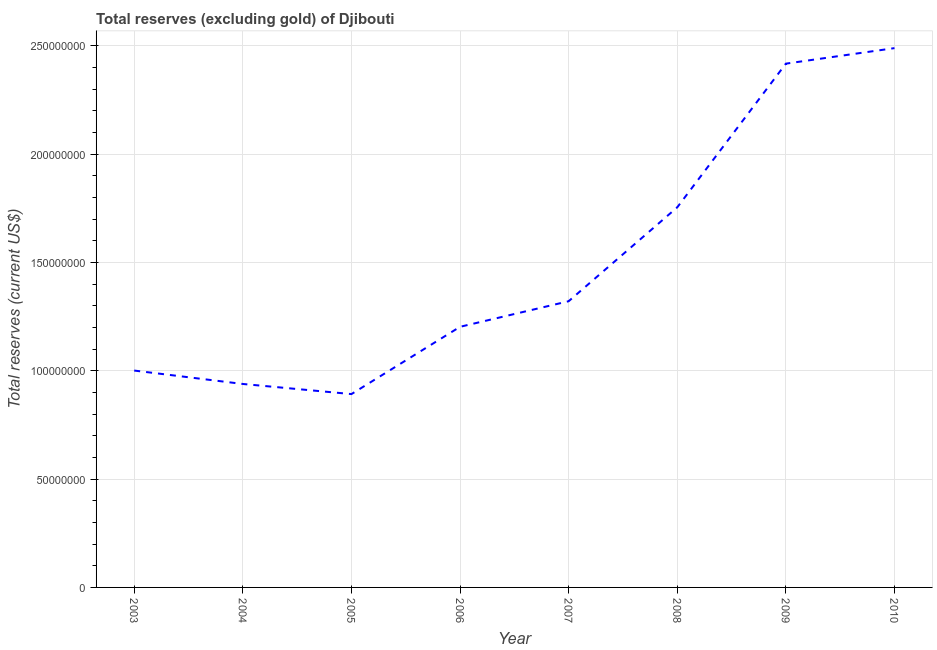What is the total reserves (excluding gold) in 2008?
Give a very brief answer. 1.75e+08. Across all years, what is the maximum total reserves (excluding gold)?
Ensure brevity in your answer.  2.49e+08. Across all years, what is the minimum total reserves (excluding gold)?
Keep it short and to the point. 8.93e+07. In which year was the total reserves (excluding gold) minimum?
Ensure brevity in your answer.  2005. What is the sum of the total reserves (excluding gold)?
Your response must be concise. 1.20e+09. What is the difference between the total reserves (excluding gold) in 2006 and 2008?
Your answer should be compact. -5.52e+07. What is the average total reserves (excluding gold) per year?
Make the answer very short. 1.50e+08. What is the median total reserves (excluding gold)?
Your response must be concise. 1.26e+08. Do a majority of the years between 2010 and 2005 (inclusive) have total reserves (excluding gold) greater than 100000000 US$?
Your answer should be compact. Yes. What is the ratio of the total reserves (excluding gold) in 2006 to that in 2010?
Your answer should be compact. 0.48. Is the total reserves (excluding gold) in 2006 less than that in 2008?
Offer a terse response. Yes. What is the difference between the highest and the second highest total reserves (excluding gold)?
Make the answer very short. 7.17e+06. What is the difference between the highest and the lowest total reserves (excluding gold)?
Your answer should be very brief. 1.60e+08. In how many years, is the total reserves (excluding gold) greater than the average total reserves (excluding gold) taken over all years?
Make the answer very short. 3. Does the total reserves (excluding gold) monotonically increase over the years?
Provide a short and direct response. No. Are the values on the major ticks of Y-axis written in scientific E-notation?
Your answer should be compact. No. What is the title of the graph?
Your answer should be compact. Total reserves (excluding gold) of Djibouti. What is the label or title of the X-axis?
Offer a terse response. Year. What is the label or title of the Y-axis?
Offer a very short reply. Total reserves (current US$). What is the Total reserves (current US$) in 2003?
Offer a terse response. 1.00e+08. What is the Total reserves (current US$) of 2004?
Your answer should be compact. 9.39e+07. What is the Total reserves (current US$) in 2005?
Keep it short and to the point. 8.93e+07. What is the Total reserves (current US$) in 2006?
Give a very brief answer. 1.20e+08. What is the Total reserves (current US$) of 2007?
Your answer should be very brief. 1.32e+08. What is the Total reserves (current US$) of 2008?
Offer a very short reply. 1.75e+08. What is the Total reserves (current US$) in 2009?
Make the answer very short. 2.42e+08. What is the Total reserves (current US$) of 2010?
Provide a succinct answer. 2.49e+08. What is the difference between the Total reserves (current US$) in 2003 and 2004?
Your response must be concise. 6.19e+06. What is the difference between the Total reserves (current US$) in 2003 and 2005?
Your answer should be compact. 1.09e+07. What is the difference between the Total reserves (current US$) in 2003 and 2006?
Offer a very short reply. -2.02e+07. What is the difference between the Total reserves (current US$) in 2003 and 2007?
Your response must be concise. -3.20e+07. What is the difference between the Total reserves (current US$) in 2003 and 2008?
Your answer should be very brief. -7.54e+07. What is the difference between the Total reserves (current US$) in 2003 and 2009?
Keep it short and to the point. -1.42e+08. What is the difference between the Total reserves (current US$) in 2003 and 2010?
Provide a succinct answer. -1.49e+08. What is the difference between the Total reserves (current US$) in 2004 and 2005?
Your response must be concise. 4.67e+06. What is the difference between the Total reserves (current US$) in 2004 and 2006?
Give a very brief answer. -2.64e+07. What is the difference between the Total reserves (current US$) in 2004 and 2007?
Ensure brevity in your answer.  -3.82e+07. What is the difference between the Total reserves (current US$) in 2004 and 2008?
Your response must be concise. -8.16e+07. What is the difference between the Total reserves (current US$) in 2004 and 2009?
Ensure brevity in your answer.  -1.48e+08. What is the difference between the Total reserves (current US$) in 2004 and 2010?
Offer a very short reply. -1.55e+08. What is the difference between the Total reserves (current US$) in 2005 and 2006?
Your response must be concise. -3.11e+07. What is the difference between the Total reserves (current US$) in 2005 and 2007?
Your answer should be very brief. -4.29e+07. What is the difference between the Total reserves (current US$) in 2005 and 2008?
Ensure brevity in your answer.  -8.62e+07. What is the difference between the Total reserves (current US$) in 2005 and 2009?
Provide a short and direct response. -1.53e+08. What is the difference between the Total reserves (current US$) in 2005 and 2010?
Offer a terse response. -1.60e+08. What is the difference between the Total reserves (current US$) in 2006 and 2007?
Give a very brief answer. -1.18e+07. What is the difference between the Total reserves (current US$) in 2006 and 2008?
Give a very brief answer. -5.52e+07. What is the difference between the Total reserves (current US$) in 2006 and 2009?
Provide a short and direct response. -1.22e+08. What is the difference between the Total reserves (current US$) in 2006 and 2010?
Provide a short and direct response. -1.29e+08. What is the difference between the Total reserves (current US$) in 2007 and 2008?
Keep it short and to the point. -4.34e+07. What is the difference between the Total reserves (current US$) in 2007 and 2009?
Offer a very short reply. -1.10e+08. What is the difference between the Total reserves (current US$) in 2007 and 2010?
Provide a succinct answer. -1.17e+08. What is the difference between the Total reserves (current US$) in 2008 and 2009?
Your answer should be compact. -6.63e+07. What is the difference between the Total reserves (current US$) in 2008 and 2010?
Offer a very short reply. -7.35e+07. What is the difference between the Total reserves (current US$) in 2009 and 2010?
Give a very brief answer. -7.17e+06. What is the ratio of the Total reserves (current US$) in 2003 to that in 2004?
Your response must be concise. 1.07. What is the ratio of the Total reserves (current US$) in 2003 to that in 2005?
Ensure brevity in your answer.  1.12. What is the ratio of the Total reserves (current US$) in 2003 to that in 2006?
Your response must be concise. 0.83. What is the ratio of the Total reserves (current US$) in 2003 to that in 2007?
Keep it short and to the point. 0.76. What is the ratio of the Total reserves (current US$) in 2003 to that in 2008?
Provide a succinct answer. 0.57. What is the ratio of the Total reserves (current US$) in 2003 to that in 2009?
Make the answer very short. 0.41. What is the ratio of the Total reserves (current US$) in 2003 to that in 2010?
Ensure brevity in your answer.  0.4. What is the ratio of the Total reserves (current US$) in 2004 to that in 2005?
Offer a very short reply. 1.05. What is the ratio of the Total reserves (current US$) in 2004 to that in 2006?
Your response must be concise. 0.78. What is the ratio of the Total reserves (current US$) in 2004 to that in 2007?
Your response must be concise. 0.71. What is the ratio of the Total reserves (current US$) in 2004 to that in 2008?
Ensure brevity in your answer.  0.54. What is the ratio of the Total reserves (current US$) in 2004 to that in 2009?
Your answer should be compact. 0.39. What is the ratio of the Total reserves (current US$) in 2004 to that in 2010?
Your answer should be very brief. 0.38. What is the ratio of the Total reserves (current US$) in 2005 to that in 2006?
Your response must be concise. 0.74. What is the ratio of the Total reserves (current US$) in 2005 to that in 2007?
Provide a short and direct response. 0.68. What is the ratio of the Total reserves (current US$) in 2005 to that in 2008?
Give a very brief answer. 0.51. What is the ratio of the Total reserves (current US$) in 2005 to that in 2009?
Your answer should be compact. 0.37. What is the ratio of the Total reserves (current US$) in 2005 to that in 2010?
Keep it short and to the point. 0.36. What is the ratio of the Total reserves (current US$) in 2006 to that in 2007?
Provide a succinct answer. 0.91. What is the ratio of the Total reserves (current US$) in 2006 to that in 2008?
Give a very brief answer. 0.69. What is the ratio of the Total reserves (current US$) in 2006 to that in 2009?
Provide a succinct answer. 0.5. What is the ratio of the Total reserves (current US$) in 2006 to that in 2010?
Provide a succinct answer. 0.48. What is the ratio of the Total reserves (current US$) in 2007 to that in 2008?
Offer a very short reply. 0.75. What is the ratio of the Total reserves (current US$) in 2007 to that in 2009?
Your response must be concise. 0.55. What is the ratio of the Total reserves (current US$) in 2007 to that in 2010?
Your answer should be compact. 0.53. What is the ratio of the Total reserves (current US$) in 2008 to that in 2009?
Offer a terse response. 0.73. What is the ratio of the Total reserves (current US$) in 2008 to that in 2010?
Your answer should be very brief. 0.7. 